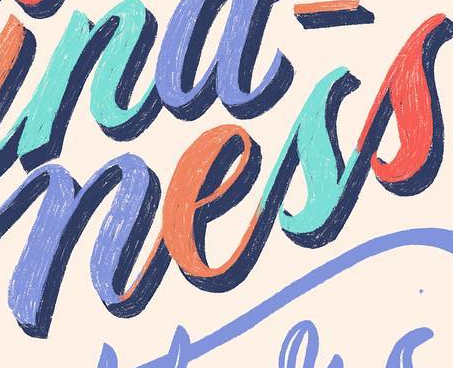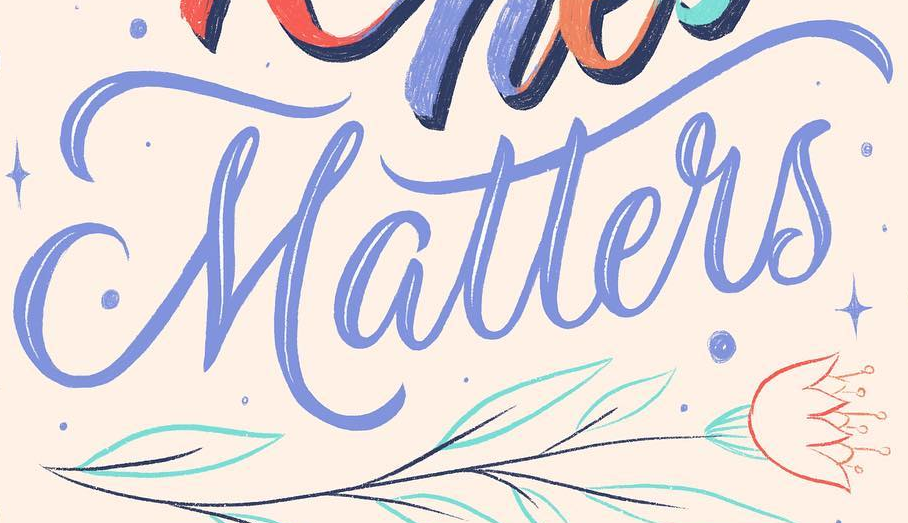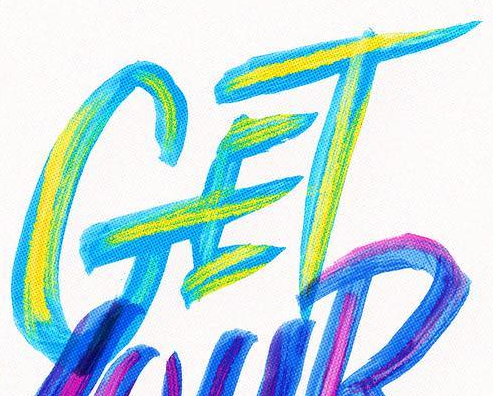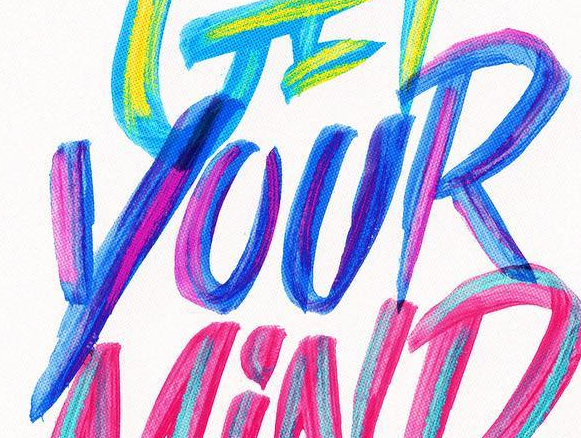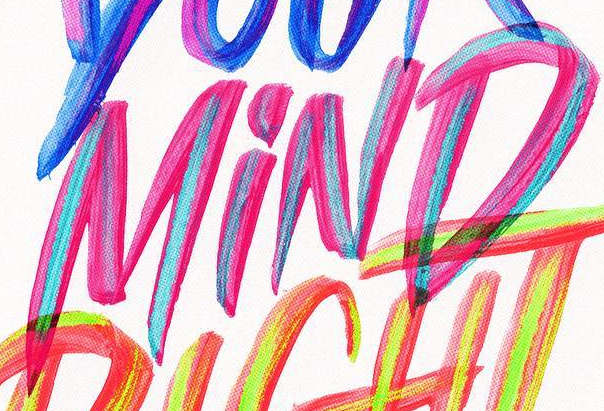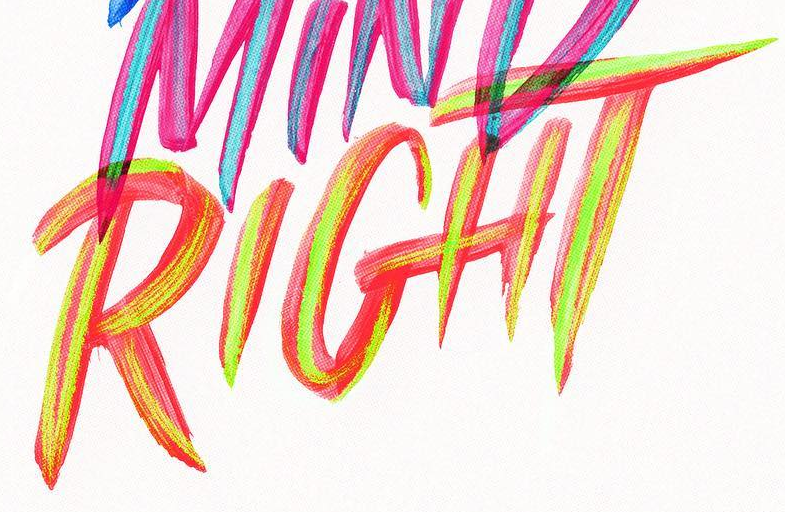What text is displayed in these images sequentially, separated by a semicolon? ness; Matters; GET; YOUR; MiND; RIGHT 